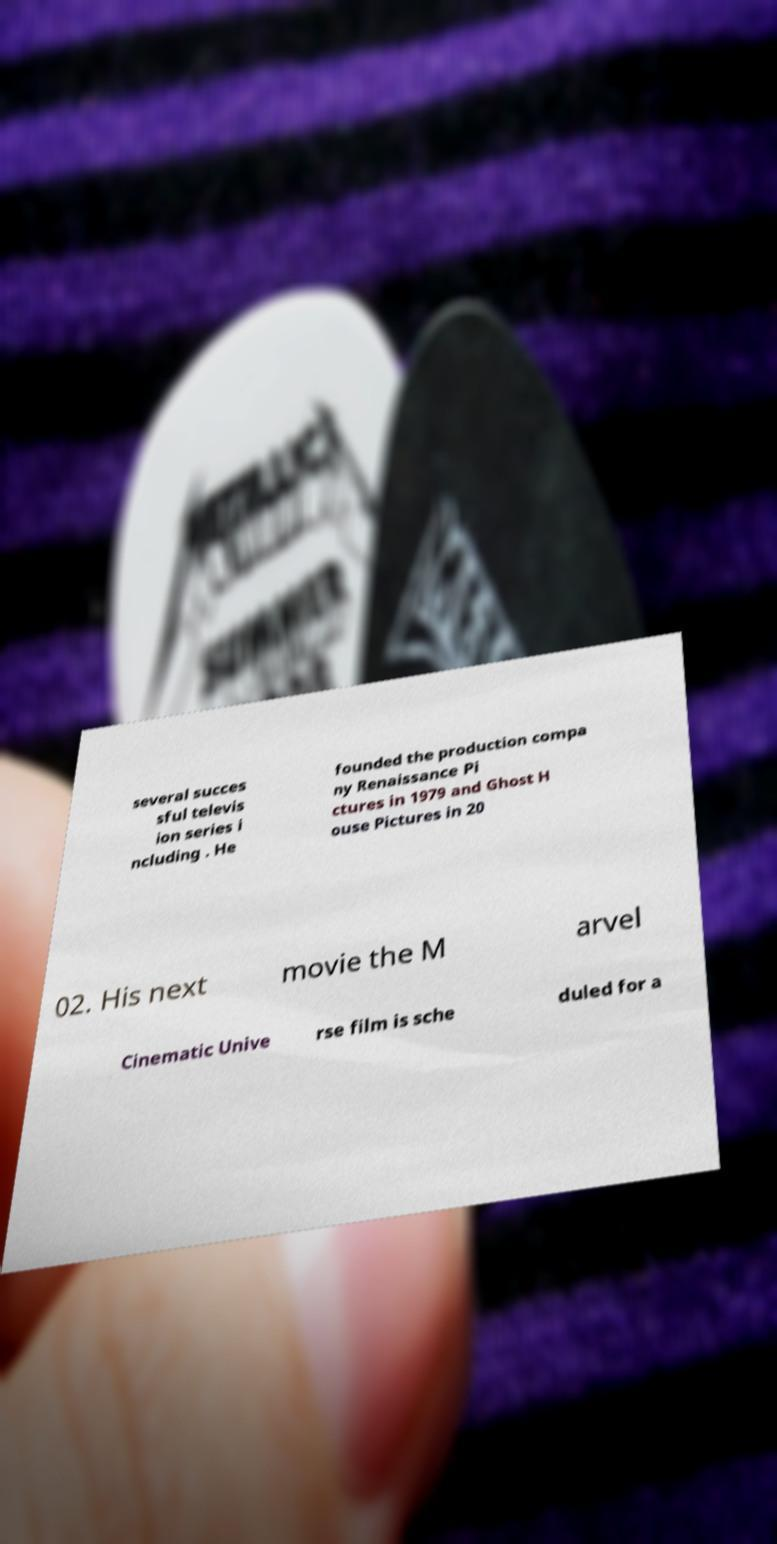There's text embedded in this image that I need extracted. Can you transcribe it verbatim? several succes sful televis ion series i ncluding . He founded the production compa ny Renaissance Pi ctures in 1979 and Ghost H ouse Pictures in 20 02. His next movie the M arvel Cinematic Unive rse film is sche duled for a 